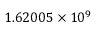<formula> <loc_0><loc_0><loc_500><loc_500>1 . 6 2 0 0 5 \times 1 0 ^ { 9 }</formula> 